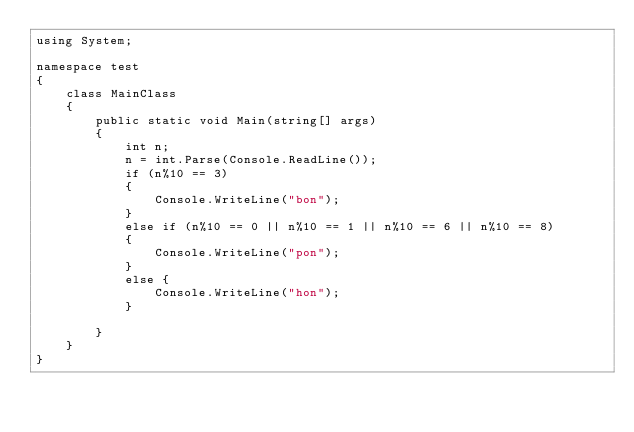Convert code to text. <code><loc_0><loc_0><loc_500><loc_500><_C#_>using System;

namespace test
{
    class MainClass
    {
        public static void Main(string[] args)
        {
            int n;
            n = int.Parse(Console.ReadLine());
            if (n%10 == 3)
            {
                Console.WriteLine("bon");
            }
            else if (n%10 == 0 || n%10 == 1 || n%10 == 6 || n%10 == 8)
            {
                Console.WriteLine("pon");
            }
            else {
                Console.WriteLine("hon");
            }

        }
    }
}
</code> 